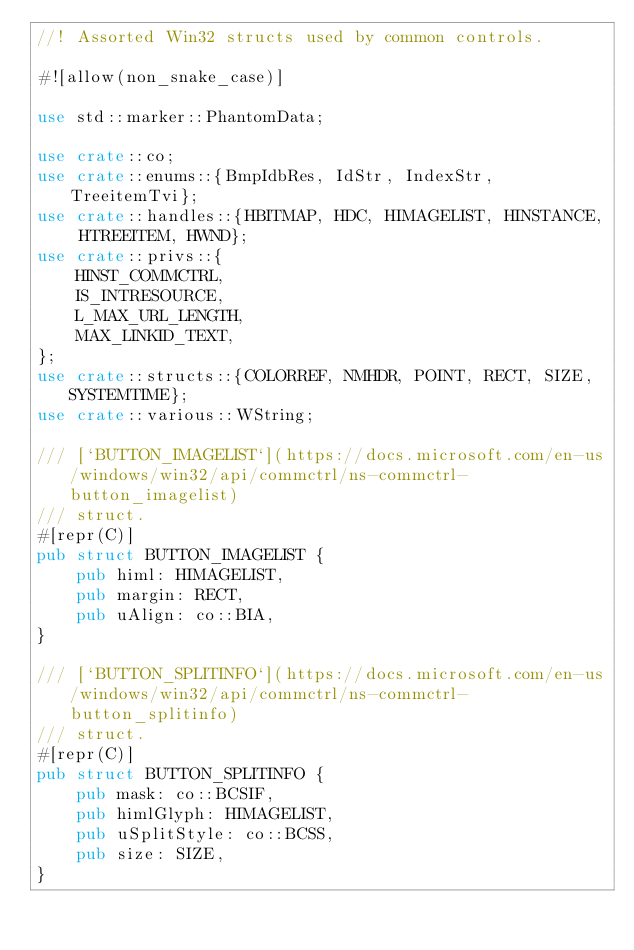Convert code to text. <code><loc_0><loc_0><loc_500><loc_500><_Rust_>//! Assorted Win32 structs used by common controls.

#![allow(non_snake_case)]

use std::marker::PhantomData;

use crate::co;
use crate::enums::{BmpIdbRes, IdStr, IndexStr, TreeitemTvi};
use crate::handles::{HBITMAP, HDC, HIMAGELIST, HINSTANCE, HTREEITEM, HWND};
use crate::privs::{
	HINST_COMMCTRL,
	IS_INTRESOURCE,
	L_MAX_URL_LENGTH,
	MAX_LINKID_TEXT,
};
use crate::structs::{COLORREF, NMHDR, POINT, RECT, SIZE, SYSTEMTIME};
use crate::various::WString;

/// [`BUTTON_IMAGELIST`](https://docs.microsoft.com/en-us/windows/win32/api/commctrl/ns-commctrl-button_imagelist)
/// struct.
#[repr(C)]
pub struct BUTTON_IMAGELIST {
	pub himl: HIMAGELIST,
	pub margin: RECT,
	pub uAlign: co::BIA,
}

/// [`BUTTON_SPLITINFO`](https://docs.microsoft.com/en-us/windows/win32/api/commctrl/ns-commctrl-button_splitinfo)
/// struct.
#[repr(C)]
pub struct BUTTON_SPLITINFO {
	pub mask: co::BCSIF,
	pub himlGlyph: HIMAGELIST,
	pub uSplitStyle: co::BCSS,
	pub size: SIZE,
}
</code> 